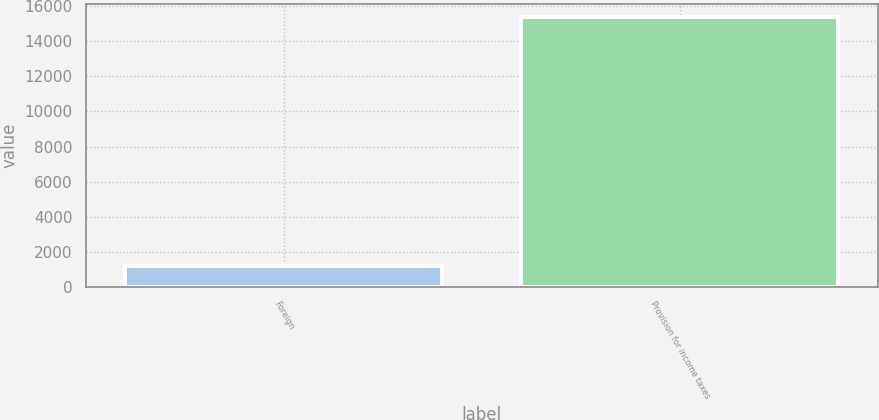<chart> <loc_0><loc_0><loc_500><loc_500><bar_chart><fcel>Foreign<fcel>Provision for income taxes<nl><fcel>1178<fcel>15378<nl></chart> 